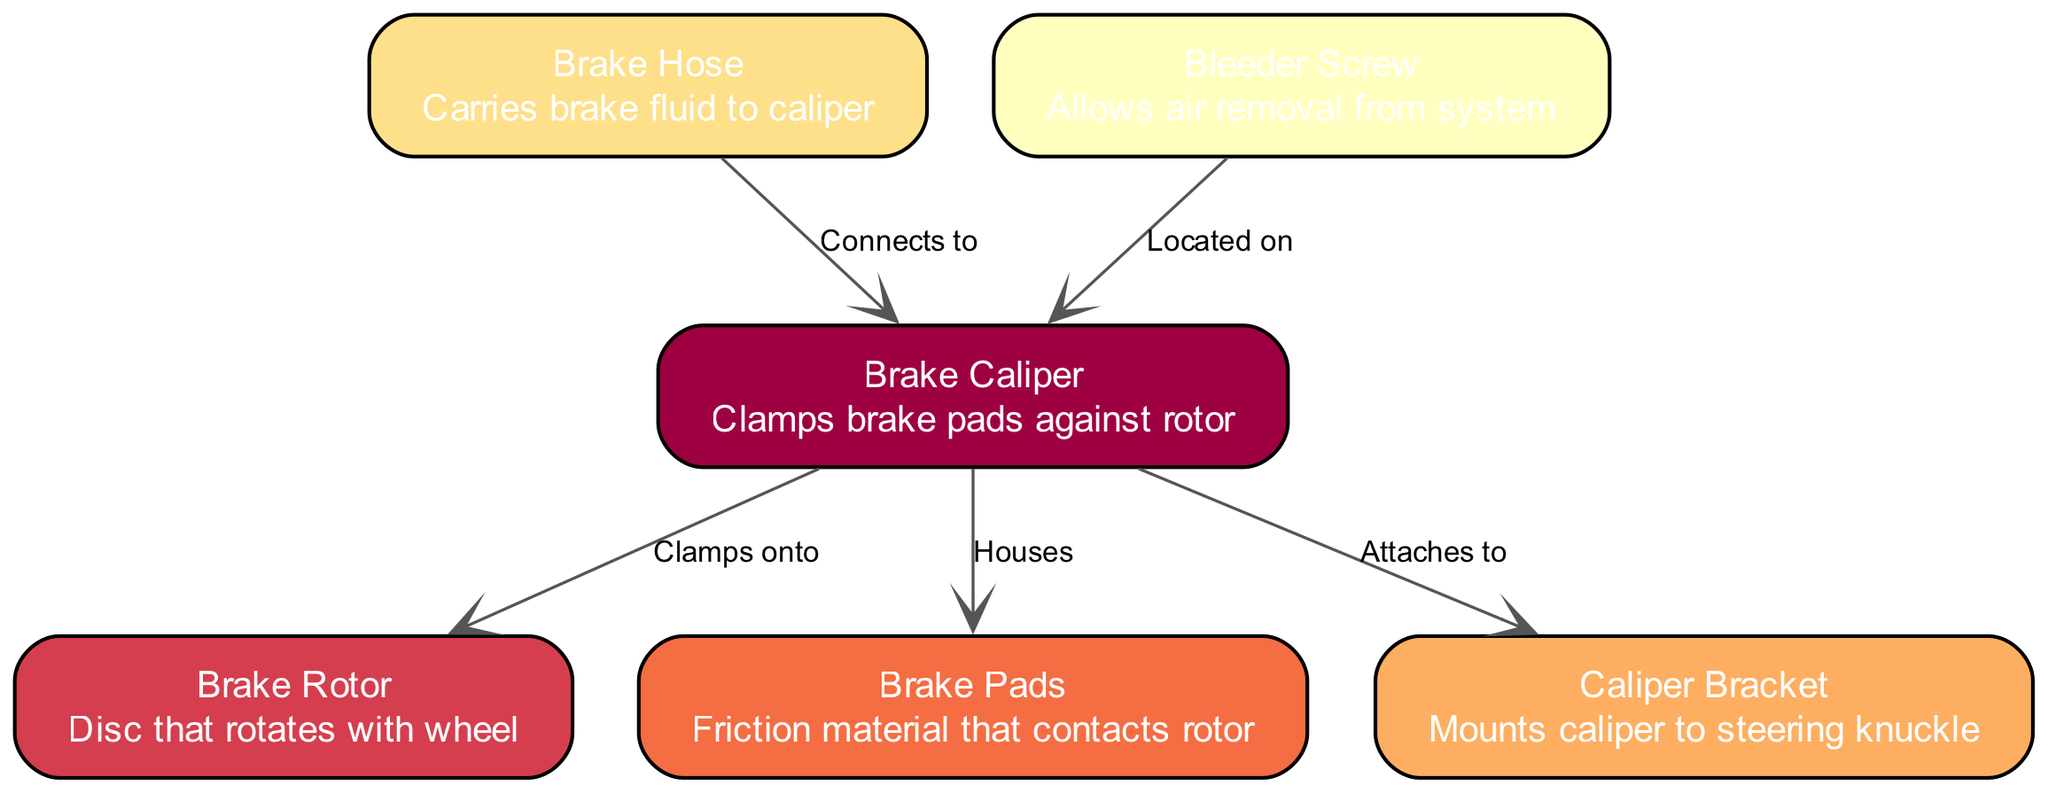What is the total number of nodes in the diagram? The diagram contains six distinct components, all represented as nodes. These components include Brake Caliper, Brake Rotor, Brake Pads, Caliper Bracket, Brake Hose, and Bleeder Screw. Thus, counting each individual component gives us a total of six nodes.
Answer: 6 What connects the Brake Caliper and Brake Hose? The direct connection illustrated in the diagram shows that the Brake Hose connects to the Brake Caliper as indicated by the label "Connects to." This relationship can be seen as the Brake Hose is responsible for delivering brake fluid to the Brake Caliper.
Answer: Brake Hose Which component houses the Brake Pads? The diagram specifies that the Brake Caliper houses the Brake Pads. This is explicitly labeled as a relationship in the edges connected to the nodes.
Answer: Brake Caliper How many edges are present in the diagram? To determine the number of connections (edges) represented in the diagram, simply count each labeled relationship connecting different nodes. In this case, there are five edges: Brake Caliper clamps onto Brake Rotor, houses Brake Pads, attaches to Caliper Bracket, Brake Hose connects to Brake Caliper, and Bleeder Screw is located on Brake Caliper.
Answer: 5 What is the function of the Bleeder Screw? The Bleeder Screw serves the essential function of allowing air removal from the brake system, which is crucial for maintaining effective braking performance. This function is succinctly described in the diagram adjacent to the Bleeder Screw node.
Answer: Air removal Which component is mounted to the steering knuckle? The relationship shown indicates that the Caliper Bracket mounts the Brake Caliper to the steering knuckle. This is indicated in the edge relationship labeled "Attaches to."
Answer: Caliper Bracket What type of diagram is this? The diagram presents an exploded view of a car's brake assembly. This specific type of engineering diagram displays all components and their relationships clearly, providing a detailed visual representation of the brake assembly.
Answer: Exploded view What does the Brake Caliper clamp onto? The diagram explicitly states that the Brake Caliper clamps onto the Brake Rotor. This connection is vital as it illustrates the direct interaction during braking.
Answer: Brake Rotor What role does the Brake Hose play in the assembly? The Brake Hose plays the role of carrying brake fluid to the Brake Caliper, essential for the operation of the brake system. This is indicated by the direct connection labeled "Connects to."
Answer: Carries brake fluid 